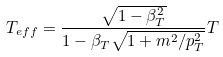Convert formula to latex. <formula><loc_0><loc_0><loc_500><loc_500>T _ { e f f } = \frac { \sqrt { 1 - \beta _ { T } ^ { 2 } } } { 1 - \beta _ { T } \sqrt { 1 + m ^ { 2 } / p _ { T } ^ { 2 } } } T</formula> 